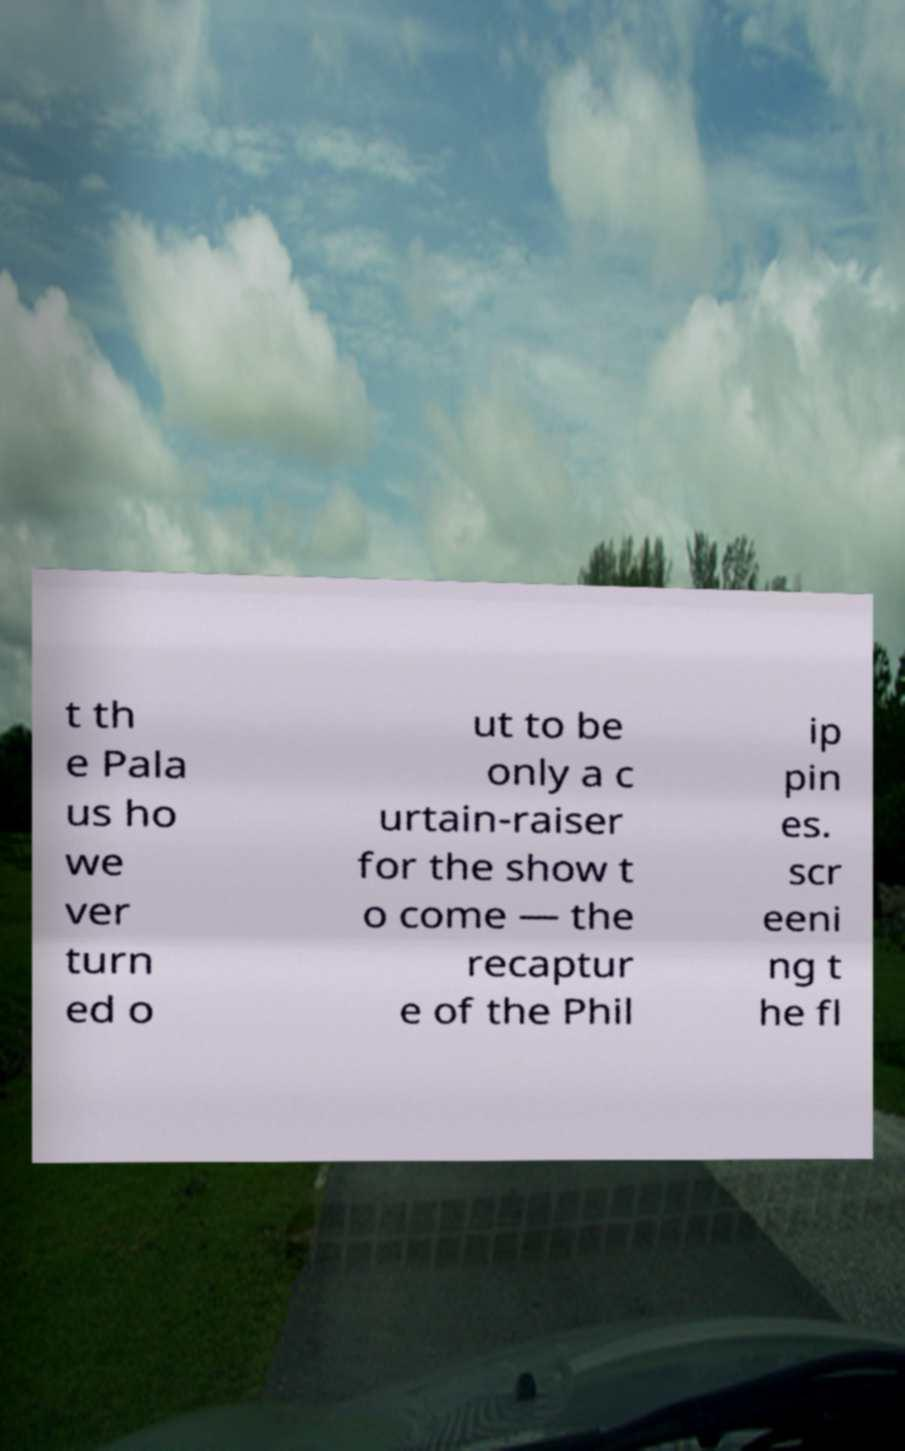What messages or text are displayed in this image? I need them in a readable, typed format. t th e Pala us ho we ver turn ed o ut to be only a c urtain-raiser for the show t o come — the recaptur e of the Phil ip pin es. scr eeni ng t he fl 